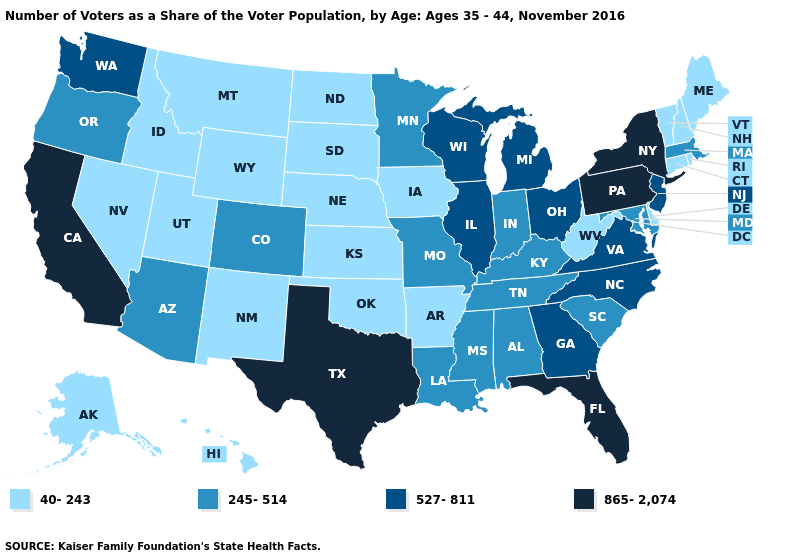Name the states that have a value in the range 40-243?
Answer briefly. Alaska, Arkansas, Connecticut, Delaware, Hawaii, Idaho, Iowa, Kansas, Maine, Montana, Nebraska, Nevada, New Hampshire, New Mexico, North Dakota, Oklahoma, Rhode Island, South Dakota, Utah, Vermont, West Virginia, Wyoming. Does Connecticut have a higher value than Idaho?
Short answer required. No. Name the states that have a value in the range 527-811?
Be succinct. Georgia, Illinois, Michigan, New Jersey, North Carolina, Ohio, Virginia, Washington, Wisconsin. What is the value of Wisconsin?
Give a very brief answer. 527-811. What is the highest value in states that border New Hampshire?
Answer briefly. 245-514. Which states have the lowest value in the USA?
Short answer required. Alaska, Arkansas, Connecticut, Delaware, Hawaii, Idaho, Iowa, Kansas, Maine, Montana, Nebraska, Nevada, New Hampshire, New Mexico, North Dakota, Oklahoma, Rhode Island, South Dakota, Utah, Vermont, West Virginia, Wyoming. What is the highest value in states that border Mississippi?
Answer briefly. 245-514. Among the states that border Minnesota , which have the lowest value?
Give a very brief answer. Iowa, North Dakota, South Dakota. What is the highest value in the West ?
Quick response, please. 865-2,074. Does New Jersey have the lowest value in the Northeast?
Answer briefly. No. Among the states that border Massachusetts , which have the highest value?
Answer briefly. New York. What is the highest value in the MidWest ?
Keep it brief. 527-811. Name the states that have a value in the range 40-243?
Be succinct. Alaska, Arkansas, Connecticut, Delaware, Hawaii, Idaho, Iowa, Kansas, Maine, Montana, Nebraska, Nevada, New Hampshire, New Mexico, North Dakota, Oklahoma, Rhode Island, South Dakota, Utah, Vermont, West Virginia, Wyoming. Does Virginia have a lower value than Texas?
Be succinct. Yes. What is the value of Louisiana?
Short answer required. 245-514. 